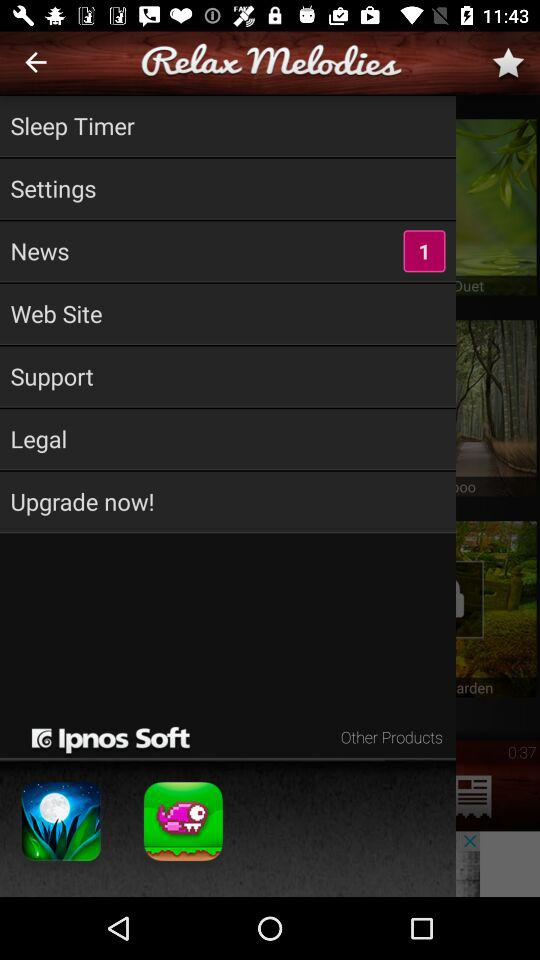What's the number of notifications in "News"? The number of notifications in "News" is 1. 